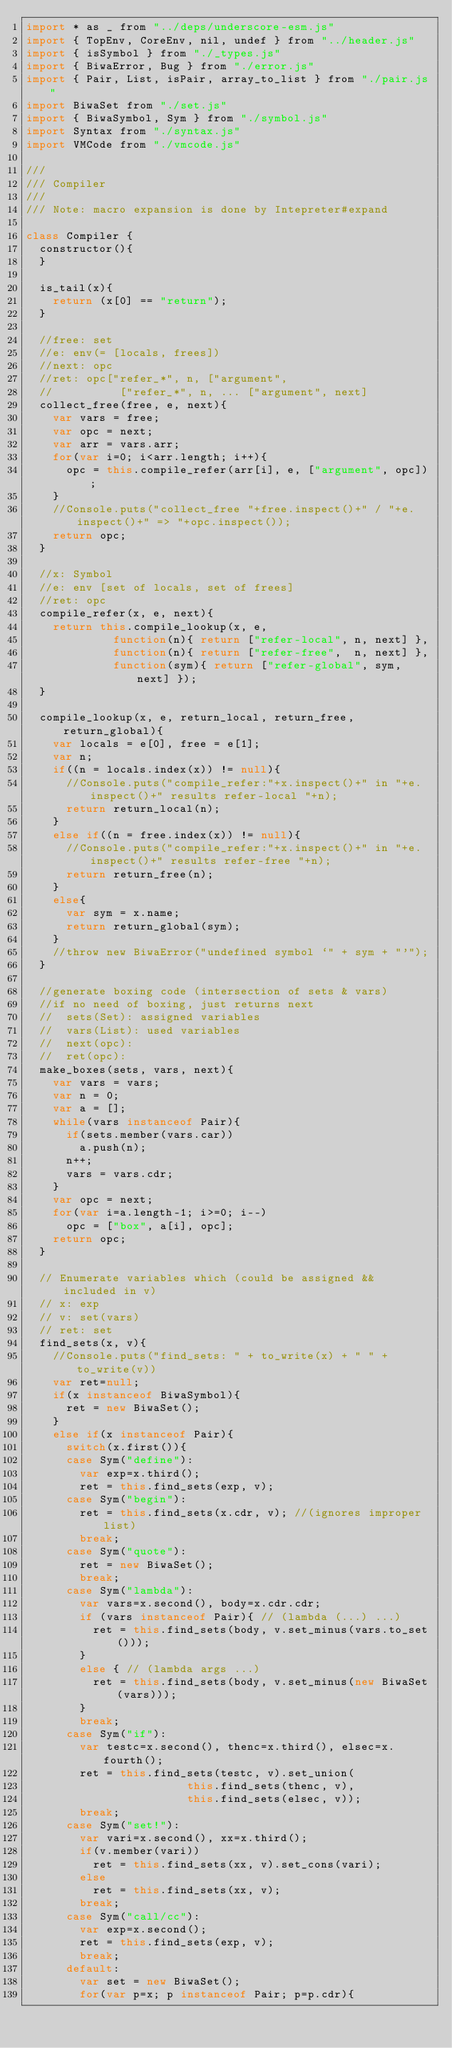Convert code to text. <code><loc_0><loc_0><loc_500><loc_500><_JavaScript_>import * as _ from "../deps/underscore-esm.js"
import { TopEnv, CoreEnv, nil, undef } from "../header.js"
import { isSymbol } from "./_types.js"
import { BiwaError, Bug } from "./error.js"
import { Pair, List, isPair, array_to_list } from "./pair.js"
import BiwaSet from "./set.js"
import { BiwaSymbol, Sym } from "./symbol.js"
import Syntax from "./syntax.js"
import VMCode from "./vmcode.js"

///
/// Compiler
///
/// Note: macro expansion is done by Intepreter#expand

class Compiler {
  constructor(){
  }

  is_tail(x){
    return (x[0] == "return");
  }

  //free: set
  //e: env(= [locals, frees])
  //next: opc
  //ret: opc["refer_*", n, ["argument", 
  //          ["refer_*", n, ... ["argument", next]
  collect_free(free, e, next){
    var vars = free;
    var opc = next;
    var arr = vars.arr;
    for(var i=0; i<arr.length; i++){
      opc = this.compile_refer(arr[i], e, ["argument", opc]);
    }
    //Console.puts("collect_free "+free.inspect()+" / "+e.inspect()+" => "+opc.inspect());
    return opc;
  }

  //x: Symbol
  //e: env [set of locals, set of frees]
  //ret: opc
  compile_refer(x, e, next){
    return this.compile_lookup(x, e,
             function(n){ return ["refer-local", n, next] },
             function(n){ return ["refer-free",  n, next] },
             function(sym){ return ["refer-global", sym, next] });
  }

  compile_lookup(x, e, return_local, return_free, return_global){
    var locals = e[0], free = e[1];
    var n;
    if((n = locals.index(x)) != null){
      //Console.puts("compile_refer:"+x.inspect()+" in "+e.inspect()+" results refer-local "+n);
      return return_local(n);
    }
    else if((n = free.index(x)) != null){
      //Console.puts("compile_refer:"+x.inspect()+" in "+e.inspect()+" results refer-free "+n);
      return return_free(n);
    }
    else{
      var sym = x.name;
      return return_global(sym);
    }
    //throw new BiwaError("undefined symbol `" + sym + "'");
  }

  //generate boxing code (intersection of sets & vars)
  //if no need of boxing, just returns next
  //  sets(Set): assigned variables 
  //  vars(List): used variables
  //  next(opc):
  //  ret(opc):
  make_boxes(sets, vars, next){
    var vars = vars;
    var n = 0;
    var a = [];
    while(vars instanceof Pair){
      if(sets.member(vars.car))
        a.push(n);
      n++;
      vars = vars.cdr;
    }
    var opc = next;
    for(var i=a.length-1; i>=0; i--)
      opc = ["box", a[i], opc];
    return opc;
  }

  // Enumerate variables which (could be assigned && included in v)
  // x: exp
  // v: set(vars)
  // ret: set
  find_sets(x, v){
    //Console.puts("find_sets: " + to_write(x) + " " + to_write(v))
    var ret=null;
    if(x instanceof BiwaSymbol){
      ret = new BiwaSet();
    }
    else if(x instanceof Pair){
      switch(x.first()){
      case Sym("define"):
        var exp=x.third();
        ret = this.find_sets(exp, v);
      case Sym("begin"):
        ret = this.find_sets(x.cdr, v); //(ignores improper list)
        break;
      case Sym("quote"):
        ret = new BiwaSet();
        break;
      case Sym("lambda"):
        var vars=x.second(), body=x.cdr.cdr;
        if (vars instanceof Pair){ // (lambda (...) ...)
          ret = this.find_sets(body, v.set_minus(vars.to_set()));
        }
        else { // (lambda args ...)
          ret = this.find_sets(body, v.set_minus(new BiwaSet(vars)));
        }
        break;
      case Sym("if"):
        var testc=x.second(), thenc=x.third(), elsec=x.fourth();
        ret = this.find_sets(testc, v).set_union(
                        this.find_sets(thenc, v),
                        this.find_sets(elsec, v));
        break;
      case Sym("set!"):
        var vari=x.second(), xx=x.third();
        if(v.member(vari))
          ret = this.find_sets(xx, v).set_cons(vari);
        else
          ret = this.find_sets(xx, v);
        break;
      case Sym("call/cc"):
        var exp=x.second();
        ret = this.find_sets(exp, v);
        break;
      default:
        var set = new BiwaSet();
        for(var p=x; p instanceof Pair; p=p.cdr){</code> 